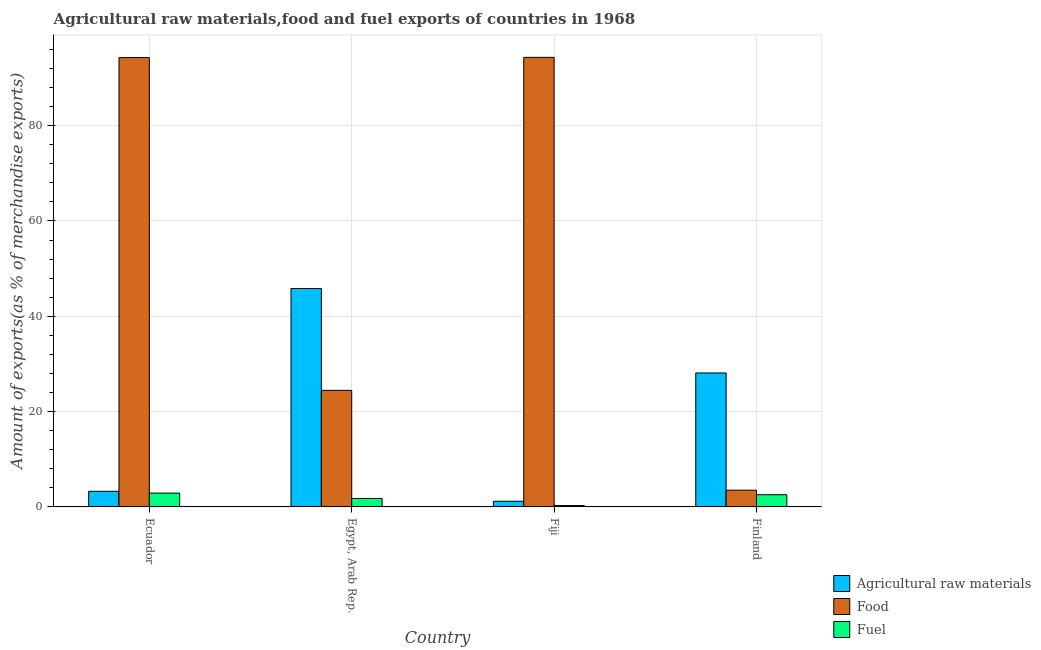How many different coloured bars are there?
Ensure brevity in your answer.  3. Are the number of bars per tick equal to the number of legend labels?
Your answer should be very brief. Yes. Are the number of bars on each tick of the X-axis equal?
Provide a succinct answer. Yes. How many bars are there on the 2nd tick from the right?
Provide a succinct answer. 3. What is the label of the 4th group of bars from the left?
Ensure brevity in your answer.  Finland. In how many cases, is the number of bars for a given country not equal to the number of legend labels?
Make the answer very short. 0. What is the percentage of fuel exports in Fiji?
Make the answer very short. 0.29. Across all countries, what is the maximum percentage of raw materials exports?
Provide a short and direct response. 45.83. Across all countries, what is the minimum percentage of food exports?
Ensure brevity in your answer.  3.52. In which country was the percentage of food exports maximum?
Provide a succinct answer. Fiji. In which country was the percentage of fuel exports minimum?
Give a very brief answer. Fiji. What is the total percentage of food exports in the graph?
Offer a very short reply. 216.6. What is the difference between the percentage of fuel exports in Egypt, Arab Rep. and that in Finland?
Provide a succinct answer. -0.79. What is the difference between the percentage of food exports in Fiji and the percentage of fuel exports in Ecuador?
Your answer should be compact. 91.43. What is the average percentage of raw materials exports per country?
Provide a short and direct response. 19.6. What is the difference between the percentage of raw materials exports and percentage of food exports in Finland?
Offer a very short reply. 24.6. In how many countries, is the percentage of fuel exports greater than 84 %?
Make the answer very short. 0. What is the ratio of the percentage of raw materials exports in Fiji to that in Finland?
Provide a succinct answer. 0.04. Is the difference between the percentage of raw materials exports in Fiji and Finland greater than the difference between the percentage of food exports in Fiji and Finland?
Provide a succinct answer. No. What is the difference between the highest and the second highest percentage of raw materials exports?
Keep it short and to the point. 17.71. What is the difference between the highest and the lowest percentage of fuel exports?
Provide a short and direct response. 2.61. In how many countries, is the percentage of food exports greater than the average percentage of food exports taken over all countries?
Offer a very short reply. 2. What does the 2nd bar from the left in Fiji represents?
Your response must be concise. Food. What does the 2nd bar from the right in Finland represents?
Offer a terse response. Food. Is it the case that in every country, the sum of the percentage of raw materials exports and percentage of food exports is greater than the percentage of fuel exports?
Your answer should be very brief. Yes. How many bars are there?
Offer a terse response. 12. Are all the bars in the graph horizontal?
Offer a terse response. No. What is the difference between two consecutive major ticks on the Y-axis?
Offer a terse response. 20. How are the legend labels stacked?
Provide a succinct answer. Vertical. What is the title of the graph?
Your response must be concise. Agricultural raw materials,food and fuel exports of countries in 1968. Does "Female employers" appear as one of the legend labels in the graph?
Make the answer very short. No. What is the label or title of the Y-axis?
Your response must be concise. Amount of exports(as % of merchandise exports). What is the Amount of exports(as % of merchandise exports) in Agricultural raw materials in Ecuador?
Offer a terse response. 3.28. What is the Amount of exports(as % of merchandise exports) of Food in Ecuador?
Give a very brief answer. 94.29. What is the Amount of exports(as % of merchandise exports) in Fuel in Ecuador?
Provide a short and direct response. 2.9. What is the Amount of exports(as % of merchandise exports) of Agricultural raw materials in Egypt, Arab Rep.?
Make the answer very short. 45.83. What is the Amount of exports(as % of merchandise exports) in Food in Egypt, Arab Rep.?
Provide a succinct answer. 24.46. What is the Amount of exports(as % of merchandise exports) of Fuel in Egypt, Arab Rep.?
Your answer should be very brief. 1.78. What is the Amount of exports(as % of merchandise exports) of Agricultural raw materials in Fiji?
Your answer should be compact. 1.19. What is the Amount of exports(as % of merchandise exports) of Food in Fiji?
Ensure brevity in your answer.  94.34. What is the Amount of exports(as % of merchandise exports) of Fuel in Fiji?
Your answer should be compact. 0.29. What is the Amount of exports(as % of merchandise exports) in Agricultural raw materials in Finland?
Offer a terse response. 28.11. What is the Amount of exports(as % of merchandise exports) of Food in Finland?
Make the answer very short. 3.52. What is the Amount of exports(as % of merchandise exports) in Fuel in Finland?
Make the answer very short. 2.57. Across all countries, what is the maximum Amount of exports(as % of merchandise exports) in Agricultural raw materials?
Keep it short and to the point. 45.83. Across all countries, what is the maximum Amount of exports(as % of merchandise exports) of Food?
Make the answer very short. 94.34. Across all countries, what is the maximum Amount of exports(as % of merchandise exports) of Fuel?
Provide a short and direct response. 2.9. Across all countries, what is the minimum Amount of exports(as % of merchandise exports) of Agricultural raw materials?
Make the answer very short. 1.19. Across all countries, what is the minimum Amount of exports(as % of merchandise exports) of Food?
Offer a very short reply. 3.52. Across all countries, what is the minimum Amount of exports(as % of merchandise exports) in Fuel?
Offer a terse response. 0.29. What is the total Amount of exports(as % of merchandise exports) of Agricultural raw materials in the graph?
Keep it short and to the point. 78.41. What is the total Amount of exports(as % of merchandise exports) in Food in the graph?
Offer a terse response. 216.6. What is the total Amount of exports(as % of merchandise exports) of Fuel in the graph?
Provide a short and direct response. 7.54. What is the difference between the Amount of exports(as % of merchandise exports) of Agricultural raw materials in Ecuador and that in Egypt, Arab Rep.?
Provide a short and direct response. -42.54. What is the difference between the Amount of exports(as % of merchandise exports) of Food in Ecuador and that in Egypt, Arab Rep.?
Offer a terse response. 69.82. What is the difference between the Amount of exports(as % of merchandise exports) in Fuel in Ecuador and that in Egypt, Arab Rep.?
Ensure brevity in your answer.  1.13. What is the difference between the Amount of exports(as % of merchandise exports) of Agricultural raw materials in Ecuador and that in Fiji?
Make the answer very short. 2.09. What is the difference between the Amount of exports(as % of merchandise exports) of Food in Ecuador and that in Fiji?
Give a very brief answer. -0.05. What is the difference between the Amount of exports(as % of merchandise exports) in Fuel in Ecuador and that in Fiji?
Keep it short and to the point. 2.61. What is the difference between the Amount of exports(as % of merchandise exports) in Agricultural raw materials in Ecuador and that in Finland?
Provide a short and direct response. -24.83. What is the difference between the Amount of exports(as % of merchandise exports) of Food in Ecuador and that in Finland?
Give a very brief answer. 90.77. What is the difference between the Amount of exports(as % of merchandise exports) in Fuel in Ecuador and that in Finland?
Your answer should be compact. 0.34. What is the difference between the Amount of exports(as % of merchandise exports) of Agricultural raw materials in Egypt, Arab Rep. and that in Fiji?
Your response must be concise. 44.63. What is the difference between the Amount of exports(as % of merchandise exports) of Food in Egypt, Arab Rep. and that in Fiji?
Give a very brief answer. -69.88. What is the difference between the Amount of exports(as % of merchandise exports) in Fuel in Egypt, Arab Rep. and that in Fiji?
Your answer should be very brief. 1.49. What is the difference between the Amount of exports(as % of merchandise exports) of Agricultural raw materials in Egypt, Arab Rep. and that in Finland?
Keep it short and to the point. 17.71. What is the difference between the Amount of exports(as % of merchandise exports) of Food in Egypt, Arab Rep. and that in Finland?
Provide a succinct answer. 20.95. What is the difference between the Amount of exports(as % of merchandise exports) of Fuel in Egypt, Arab Rep. and that in Finland?
Provide a short and direct response. -0.79. What is the difference between the Amount of exports(as % of merchandise exports) of Agricultural raw materials in Fiji and that in Finland?
Ensure brevity in your answer.  -26.92. What is the difference between the Amount of exports(as % of merchandise exports) of Food in Fiji and that in Finland?
Ensure brevity in your answer.  90.82. What is the difference between the Amount of exports(as % of merchandise exports) of Fuel in Fiji and that in Finland?
Your response must be concise. -2.28. What is the difference between the Amount of exports(as % of merchandise exports) of Agricultural raw materials in Ecuador and the Amount of exports(as % of merchandise exports) of Food in Egypt, Arab Rep.?
Keep it short and to the point. -21.18. What is the difference between the Amount of exports(as % of merchandise exports) in Agricultural raw materials in Ecuador and the Amount of exports(as % of merchandise exports) in Fuel in Egypt, Arab Rep.?
Your answer should be compact. 1.5. What is the difference between the Amount of exports(as % of merchandise exports) of Food in Ecuador and the Amount of exports(as % of merchandise exports) of Fuel in Egypt, Arab Rep.?
Ensure brevity in your answer.  92.51. What is the difference between the Amount of exports(as % of merchandise exports) in Agricultural raw materials in Ecuador and the Amount of exports(as % of merchandise exports) in Food in Fiji?
Ensure brevity in your answer.  -91.06. What is the difference between the Amount of exports(as % of merchandise exports) of Agricultural raw materials in Ecuador and the Amount of exports(as % of merchandise exports) of Fuel in Fiji?
Keep it short and to the point. 2.99. What is the difference between the Amount of exports(as % of merchandise exports) of Food in Ecuador and the Amount of exports(as % of merchandise exports) of Fuel in Fiji?
Offer a very short reply. 94. What is the difference between the Amount of exports(as % of merchandise exports) in Agricultural raw materials in Ecuador and the Amount of exports(as % of merchandise exports) in Food in Finland?
Your response must be concise. -0.24. What is the difference between the Amount of exports(as % of merchandise exports) in Agricultural raw materials in Ecuador and the Amount of exports(as % of merchandise exports) in Fuel in Finland?
Your response must be concise. 0.71. What is the difference between the Amount of exports(as % of merchandise exports) of Food in Ecuador and the Amount of exports(as % of merchandise exports) of Fuel in Finland?
Keep it short and to the point. 91.72. What is the difference between the Amount of exports(as % of merchandise exports) in Agricultural raw materials in Egypt, Arab Rep. and the Amount of exports(as % of merchandise exports) in Food in Fiji?
Keep it short and to the point. -48.51. What is the difference between the Amount of exports(as % of merchandise exports) of Agricultural raw materials in Egypt, Arab Rep. and the Amount of exports(as % of merchandise exports) of Fuel in Fiji?
Keep it short and to the point. 45.53. What is the difference between the Amount of exports(as % of merchandise exports) of Food in Egypt, Arab Rep. and the Amount of exports(as % of merchandise exports) of Fuel in Fiji?
Provide a short and direct response. 24.17. What is the difference between the Amount of exports(as % of merchandise exports) in Agricultural raw materials in Egypt, Arab Rep. and the Amount of exports(as % of merchandise exports) in Food in Finland?
Ensure brevity in your answer.  42.31. What is the difference between the Amount of exports(as % of merchandise exports) of Agricultural raw materials in Egypt, Arab Rep. and the Amount of exports(as % of merchandise exports) of Fuel in Finland?
Offer a terse response. 43.26. What is the difference between the Amount of exports(as % of merchandise exports) in Food in Egypt, Arab Rep. and the Amount of exports(as % of merchandise exports) in Fuel in Finland?
Your answer should be compact. 21.89. What is the difference between the Amount of exports(as % of merchandise exports) of Agricultural raw materials in Fiji and the Amount of exports(as % of merchandise exports) of Food in Finland?
Your answer should be very brief. -2.32. What is the difference between the Amount of exports(as % of merchandise exports) in Agricultural raw materials in Fiji and the Amount of exports(as % of merchandise exports) in Fuel in Finland?
Offer a very short reply. -1.37. What is the difference between the Amount of exports(as % of merchandise exports) in Food in Fiji and the Amount of exports(as % of merchandise exports) in Fuel in Finland?
Your response must be concise. 91.77. What is the average Amount of exports(as % of merchandise exports) in Agricultural raw materials per country?
Offer a terse response. 19.6. What is the average Amount of exports(as % of merchandise exports) in Food per country?
Make the answer very short. 54.15. What is the average Amount of exports(as % of merchandise exports) in Fuel per country?
Give a very brief answer. 1.88. What is the difference between the Amount of exports(as % of merchandise exports) of Agricultural raw materials and Amount of exports(as % of merchandise exports) of Food in Ecuador?
Your answer should be compact. -91. What is the difference between the Amount of exports(as % of merchandise exports) in Agricultural raw materials and Amount of exports(as % of merchandise exports) in Fuel in Ecuador?
Your answer should be compact. 0.38. What is the difference between the Amount of exports(as % of merchandise exports) of Food and Amount of exports(as % of merchandise exports) of Fuel in Ecuador?
Offer a very short reply. 91.38. What is the difference between the Amount of exports(as % of merchandise exports) of Agricultural raw materials and Amount of exports(as % of merchandise exports) of Food in Egypt, Arab Rep.?
Keep it short and to the point. 21.36. What is the difference between the Amount of exports(as % of merchandise exports) in Agricultural raw materials and Amount of exports(as % of merchandise exports) in Fuel in Egypt, Arab Rep.?
Your response must be concise. 44.05. What is the difference between the Amount of exports(as % of merchandise exports) of Food and Amount of exports(as % of merchandise exports) of Fuel in Egypt, Arab Rep.?
Your answer should be very brief. 22.68. What is the difference between the Amount of exports(as % of merchandise exports) in Agricultural raw materials and Amount of exports(as % of merchandise exports) in Food in Fiji?
Offer a very short reply. -93.15. What is the difference between the Amount of exports(as % of merchandise exports) of Agricultural raw materials and Amount of exports(as % of merchandise exports) of Fuel in Fiji?
Make the answer very short. 0.9. What is the difference between the Amount of exports(as % of merchandise exports) in Food and Amount of exports(as % of merchandise exports) in Fuel in Fiji?
Your response must be concise. 94.05. What is the difference between the Amount of exports(as % of merchandise exports) of Agricultural raw materials and Amount of exports(as % of merchandise exports) of Food in Finland?
Your answer should be very brief. 24.6. What is the difference between the Amount of exports(as % of merchandise exports) in Agricultural raw materials and Amount of exports(as % of merchandise exports) in Fuel in Finland?
Offer a very short reply. 25.54. What is the difference between the Amount of exports(as % of merchandise exports) in Food and Amount of exports(as % of merchandise exports) in Fuel in Finland?
Offer a terse response. 0.95. What is the ratio of the Amount of exports(as % of merchandise exports) of Agricultural raw materials in Ecuador to that in Egypt, Arab Rep.?
Offer a very short reply. 0.07. What is the ratio of the Amount of exports(as % of merchandise exports) in Food in Ecuador to that in Egypt, Arab Rep.?
Your response must be concise. 3.85. What is the ratio of the Amount of exports(as % of merchandise exports) in Fuel in Ecuador to that in Egypt, Arab Rep.?
Your answer should be compact. 1.63. What is the ratio of the Amount of exports(as % of merchandise exports) in Agricultural raw materials in Ecuador to that in Fiji?
Provide a short and direct response. 2.75. What is the ratio of the Amount of exports(as % of merchandise exports) of Fuel in Ecuador to that in Fiji?
Keep it short and to the point. 10. What is the ratio of the Amount of exports(as % of merchandise exports) in Agricultural raw materials in Ecuador to that in Finland?
Provide a succinct answer. 0.12. What is the ratio of the Amount of exports(as % of merchandise exports) of Food in Ecuador to that in Finland?
Keep it short and to the point. 26.82. What is the ratio of the Amount of exports(as % of merchandise exports) in Fuel in Ecuador to that in Finland?
Provide a short and direct response. 1.13. What is the ratio of the Amount of exports(as % of merchandise exports) in Agricultural raw materials in Egypt, Arab Rep. to that in Fiji?
Your answer should be very brief. 38.4. What is the ratio of the Amount of exports(as % of merchandise exports) in Food in Egypt, Arab Rep. to that in Fiji?
Your answer should be compact. 0.26. What is the ratio of the Amount of exports(as % of merchandise exports) in Fuel in Egypt, Arab Rep. to that in Fiji?
Provide a succinct answer. 6.12. What is the ratio of the Amount of exports(as % of merchandise exports) in Agricultural raw materials in Egypt, Arab Rep. to that in Finland?
Ensure brevity in your answer.  1.63. What is the ratio of the Amount of exports(as % of merchandise exports) of Food in Egypt, Arab Rep. to that in Finland?
Offer a terse response. 6.96. What is the ratio of the Amount of exports(as % of merchandise exports) in Fuel in Egypt, Arab Rep. to that in Finland?
Make the answer very short. 0.69. What is the ratio of the Amount of exports(as % of merchandise exports) of Agricultural raw materials in Fiji to that in Finland?
Your response must be concise. 0.04. What is the ratio of the Amount of exports(as % of merchandise exports) of Food in Fiji to that in Finland?
Ensure brevity in your answer.  26.83. What is the ratio of the Amount of exports(as % of merchandise exports) of Fuel in Fiji to that in Finland?
Offer a terse response. 0.11. What is the difference between the highest and the second highest Amount of exports(as % of merchandise exports) of Agricultural raw materials?
Give a very brief answer. 17.71. What is the difference between the highest and the second highest Amount of exports(as % of merchandise exports) in Food?
Provide a succinct answer. 0.05. What is the difference between the highest and the second highest Amount of exports(as % of merchandise exports) of Fuel?
Make the answer very short. 0.34. What is the difference between the highest and the lowest Amount of exports(as % of merchandise exports) in Agricultural raw materials?
Your answer should be compact. 44.63. What is the difference between the highest and the lowest Amount of exports(as % of merchandise exports) in Food?
Keep it short and to the point. 90.82. What is the difference between the highest and the lowest Amount of exports(as % of merchandise exports) of Fuel?
Make the answer very short. 2.61. 